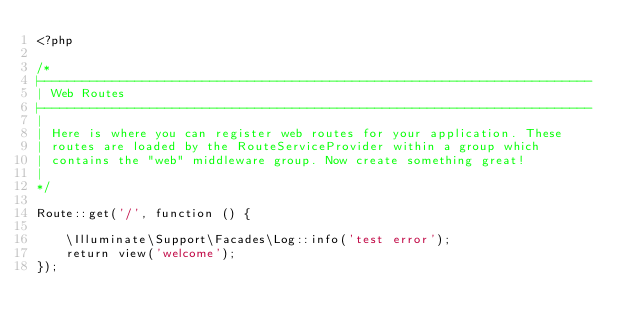Convert code to text. <code><loc_0><loc_0><loc_500><loc_500><_PHP_><?php

/*
|--------------------------------------------------------------------------
| Web Routes
|--------------------------------------------------------------------------
|
| Here is where you can register web routes for your application. These
| routes are loaded by the RouteServiceProvider within a group which
| contains the "web" middleware group. Now create something great!
|
*/

Route::get('/', function () {

    \Illuminate\Support\Facades\Log::info('test error');
    return view('welcome');
});
</code> 